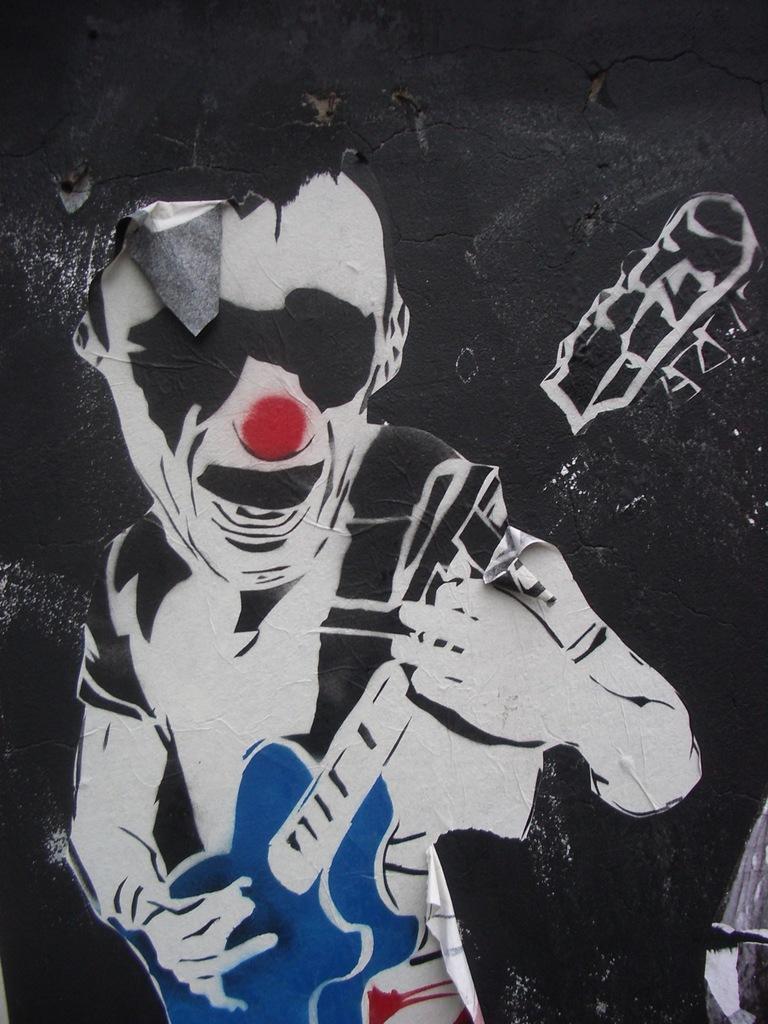How would you summarize this image in a sentence or two? In this picture we can see poster of a person playing a guitar on the wall. 